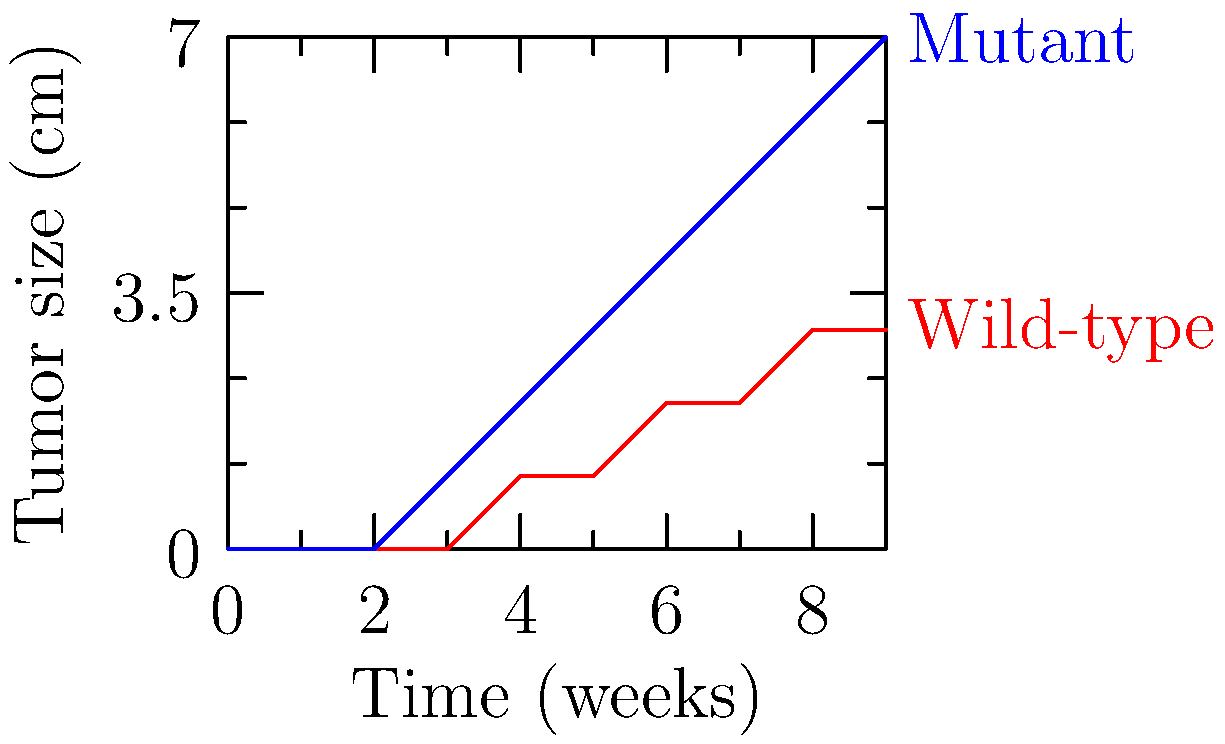Based on the DNA sequence alignment and tumor growth data shown in the graph, which of the following statements best describes the key mutation likely responsible for the accelerated cancer progression in the mutant strain?

A) A missense mutation in the p53 tumor suppressor gene
B) A frameshift mutation in the BRCA1 gene
C) An in-frame deletion in the RAS oncogene
D) A nonsense mutation in the APC gene To identify the key mutation responsible for accelerated cancer progression, we need to analyze the graph and consider the molecular basis of cancer:

1. The graph shows two growth curves: wild-type (red) and mutant (blue).
2. The mutant strain exhibits significantly faster tumor growth compared to the wild-type.
3. The growth pattern suggests a loss of growth control and increased proliferation.

Now, let's consider each option:

A) p53 is a crucial tumor suppressor gene that regulates cell cycle arrest and apoptosis. A missense mutation in p53 could lead to loss of function, resulting in uncontrolled cell growth.

B) BRCA1 is involved in DNA repair and maintaining genomic stability. A frameshift mutation would likely cause complete loss of function, but its effects are more commonly associated with increased cancer risk rather than accelerated progression.

C) RAS is a proto-oncogene involved in cell signaling and growth. An in-frame deletion might not significantly alter its function or could even decrease its activity.

D) APC is a tumor suppressor gene primarily associated with colorectal cancer. A nonsense mutation would cause premature termination of the protein, but its effects are typically more specific to certain cancer types.

Considering the rapid and consistent increase in tumor size shown in the graph, option A (missense mutation in p53) is the most likely explanation. A partially functional p53 protein resulting from a missense mutation could allow for accelerated growth while maintaining some level of cellular viability, consistent with the observed growth curve.
Answer: A) A missense mutation in the p53 tumor suppressor gene 